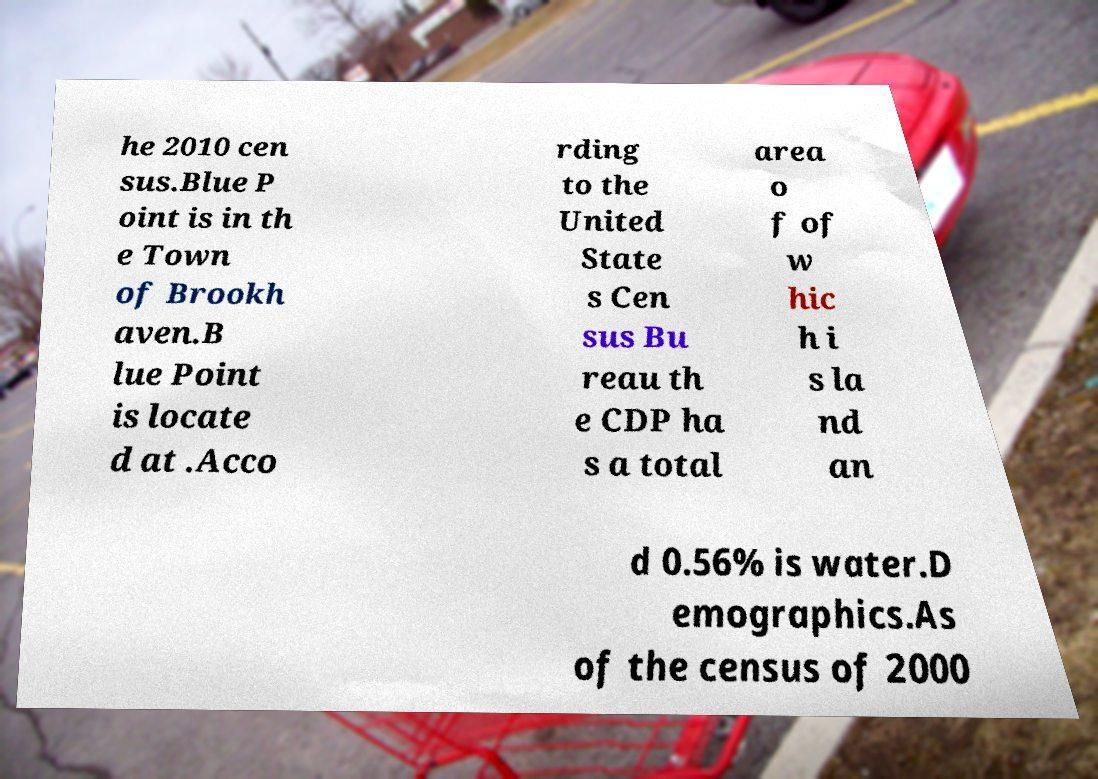I need the written content from this picture converted into text. Can you do that? he 2010 cen sus.Blue P oint is in th e Town of Brookh aven.B lue Point is locate d at .Acco rding to the United State s Cen sus Bu reau th e CDP ha s a total area o f of w hic h i s la nd an d 0.56% is water.D emographics.As of the census of 2000 